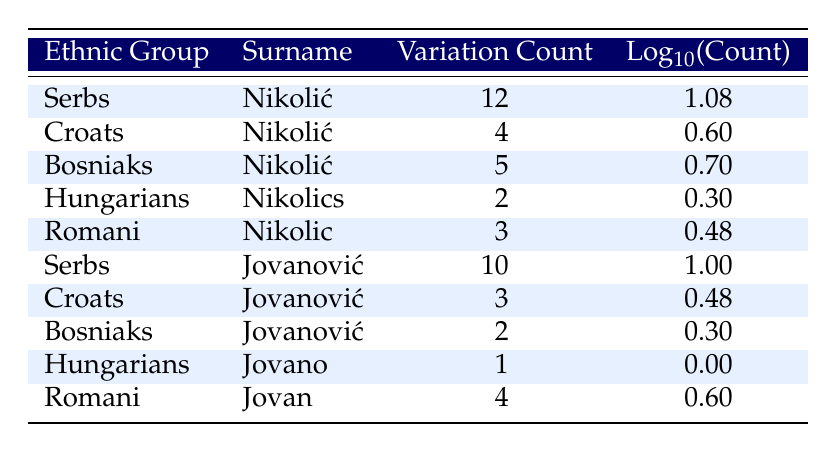What is the variation count of the surname "Nikolić" among Serbs? The table lists the ethnic group "Serbs" alongside the surname "Nikolić," showing a variation count of 12.
Answer: 12 How many variation counts are there for the surname "Jovanović" among Croats? The table shows the surname "Jovanović" listed under the ethnic group "Croats" with a variation count of 3.
Answer: 3 Is the variation count for the surname "Nikolić" among Bosniaks greater than that among Hungarians? The table shows that the variation count for "Nikolić" among Bosniaks is 5, while for Hungarians it is 2. Since 5 is greater than 2, the statement is true.
Answer: Yes What is the total variation count for the surname "Jovanović" across all ethnic groups listed? To find the total variation count for "Jovanović," we add the counts from all ethnic groups: 10 (Serbs) + 3 (Croats) + 2 (Bosniaks) + 1 (Hungarians) + 4 (Romani) = 20.
Answer: 20 Which ethnic group has the highest variation count for the surname "Nikolić"? According to the table, the ethnic group "Serbs" has the highest variation count for "Nikolić" at 12.
Answer: Serbs What is the average variation count for the surname "Nikolić" across all ethnic groups listed? The variation counts for "Nikolić" are 12 (Serbs), 4 (Croats), 5 (Bosniaks), 2 (Hungarians), and 3 (Romani). Adding these gives a total of 26. There are 5 ethnic groups, so the average variation count is 26/5 = 5.2.
Answer: 5.2 Is there a variation of the surname "Jovanović" among Hungarians? The table shows that there is no variation for "Jovanović" among Hungarians as the count is listed as 1 for the surname "Jovano," which is a different variation.
Answer: No How many more variations of the surname "Nikolić" are there among Serbs compared to Romani? The variation count for "Nikolić" among Serbs is 12, and among Romani is 3. The difference between these counts is 12 - 3 = 9.
Answer: 9 What is the highest logarithmic value of variation count for any surname listed in the table? The highest variation count is for "Nikolić" among Serbs at 12, and its logarithmic value is log10(12) = 1.08. Comparison to all other logarithmic values confirms this is the highest.
Answer: 1.08 